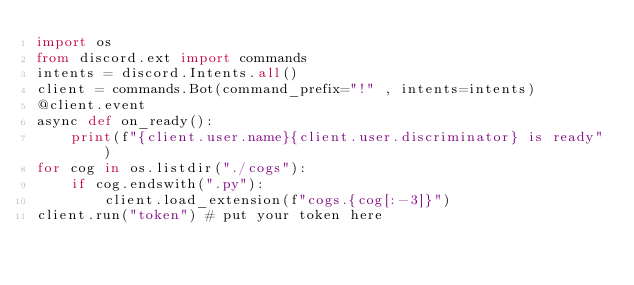Convert code to text. <code><loc_0><loc_0><loc_500><loc_500><_Python_>import os
from discord.ext import commands
intents = discord.Intents.all()
client = commands.Bot(command_prefix="!" , intents=intents)
@client.event
async def on_ready():
    print(f"{client.user.name}{client.user.discriminator} is ready")
for cog in os.listdir("./cogs"):
    if cog.endswith(".py"):
        client.load_extension(f"cogs.{cog[:-3]}")
client.run("token") # put your token here
</code> 